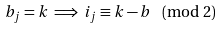Convert formula to latex. <formula><loc_0><loc_0><loc_500><loc_500>b _ { j } = k \implies i _ { j } \equiv k - b \pmod { 2 }</formula> 